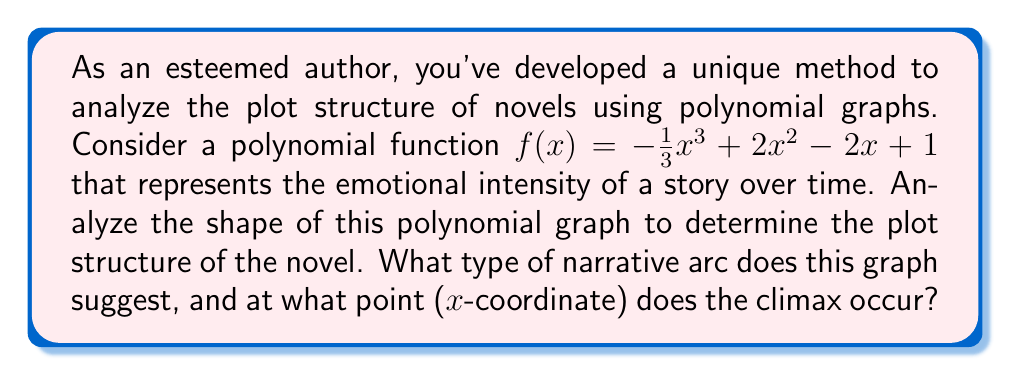Could you help me with this problem? To analyze the plot structure using the polynomial graph, we'll follow these steps:

1. Determine the shape of the graph:
   The polynomial $f(x) = -\frac{1}{3}x^3 + 2x^2 - 2x + 1$ is a cubic function with a negative leading coefficient. This means the graph will have one turning point (local maximum) and one point of inflection.

2. Find the critical points:
   Take the derivative: $f'(x) = -x^2 + 4x - 2$
   Set $f'(x) = 0$ and solve:
   $-x^2 + 4x - 2 = 0$
   $(x - 1)(x - 3) = 0$
   $x = 1$ or $x = 3$

3. Determine the nature of critical points:
   The second derivative is $f''(x) = -2x + 4$
   At $x = 1$: $f''(1) = 2 > 0$, so this is a local minimum
   At $x = 3$: $f''(3) = -2 < 0$, so this is a local maximum

4. Interpret the graph:
   The graph starts at a moderate level (y-intercept at 1), decreases to a local minimum at $x = 1$, then rises to a local maximum at $x = 3$, and finally decreases again.

5. Relate to narrative structure:
   This shape suggests a classic narrative arc:
   - Introduction: Start at moderate intensity
   - Rising action: Intensity increases from $x = 1$ to $x = 3$
   - Climax: Peak at $x = 3$
   - Falling action and resolution: Decreasing intensity after $x = 3$

Therefore, the narrative arc suggested by this graph is a classic "rising action to climax" structure, with the climax occurring at the x-coordinate of 3.
Answer: Classic "rising action to climax" structure; climax at x = 3 